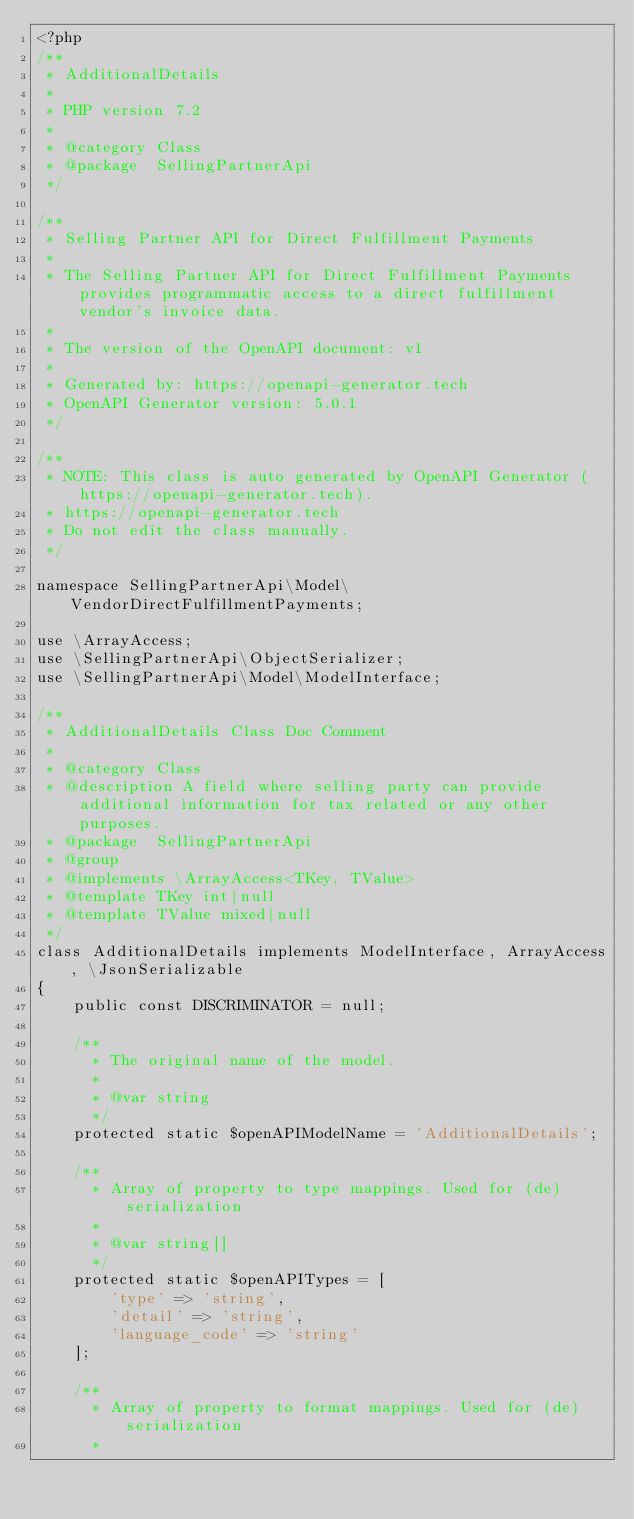<code> <loc_0><loc_0><loc_500><loc_500><_PHP_><?php
/**
 * AdditionalDetails
 *
 * PHP version 7.2
 *
 * @category Class
 * @package  SellingPartnerApi
 */

/**
 * Selling Partner API for Direct Fulfillment Payments
 *
 * The Selling Partner API for Direct Fulfillment Payments provides programmatic access to a direct fulfillment vendor's invoice data.
 *
 * The version of the OpenAPI document: v1
 * 
 * Generated by: https://openapi-generator.tech
 * OpenAPI Generator version: 5.0.1
 */

/**
 * NOTE: This class is auto generated by OpenAPI Generator (https://openapi-generator.tech).
 * https://openapi-generator.tech
 * Do not edit the class manually.
 */

namespace SellingPartnerApi\Model\VendorDirectFulfillmentPayments;

use \ArrayAccess;
use \SellingPartnerApi\ObjectSerializer;
use \SellingPartnerApi\Model\ModelInterface;

/**
 * AdditionalDetails Class Doc Comment
 *
 * @category Class
 * @description A field where selling party can provide additional information for tax related or any other purposes.
 * @package  SellingPartnerApi
 * @group 
 * @implements \ArrayAccess<TKey, TValue>
 * @template TKey int|null
 * @template TValue mixed|null  
 */
class AdditionalDetails implements ModelInterface, ArrayAccess, \JsonSerializable
{
    public const DISCRIMINATOR = null;

    /**
      * The original name of the model.
      *
      * @var string
      */
    protected static $openAPIModelName = 'AdditionalDetails';

    /**
      * Array of property to type mappings. Used for (de)serialization
      *
      * @var string[]
      */
    protected static $openAPITypes = [
        'type' => 'string',
        'detail' => 'string',
        'language_code' => 'string'
    ];

    /**
      * Array of property to format mappings. Used for (de)serialization
      *</code> 